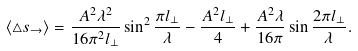<formula> <loc_0><loc_0><loc_500><loc_500>\langle \triangle s _ { \rightarrow } \rangle = \frac { A ^ { 2 } \lambda ^ { 2 } } { 1 6 \pi ^ { 2 } l _ { \perp } } \sin ^ { 2 } \frac { \pi l _ { \perp } } { \lambda } - \frac { A ^ { 2 } l _ { \perp } } { 4 } + \frac { A ^ { 2 } \lambda } { 1 6 \pi } \sin \frac { 2 \pi l _ { \perp } } { \lambda } .</formula> 